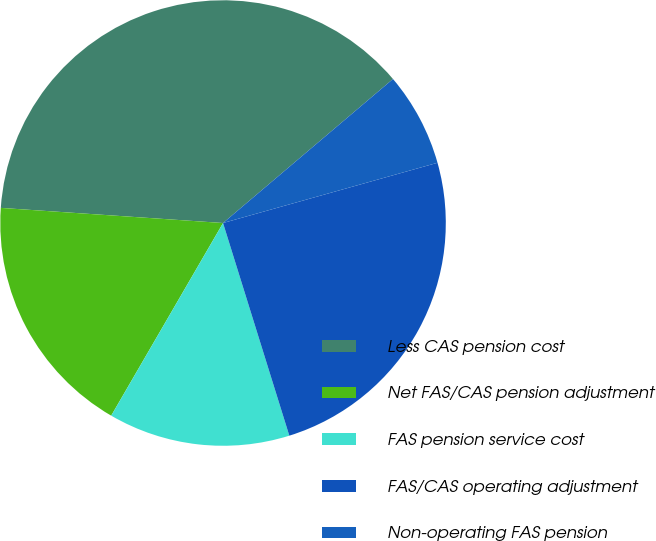Convert chart. <chart><loc_0><loc_0><loc_500><loc_500><pie_chart><fcel>Less CAS pension cost<fcel>Net FAS/CAS pension adjustment<fcel>FAS pension service cost<fcel>FAS/CAS operating adjustment<fcel>Non-operating FAS pension<nl><fcel>37.73%<fcel>17.71%<fcel>13.18%<fcel>24.55%<fcel>6.83%<nl></chart> 